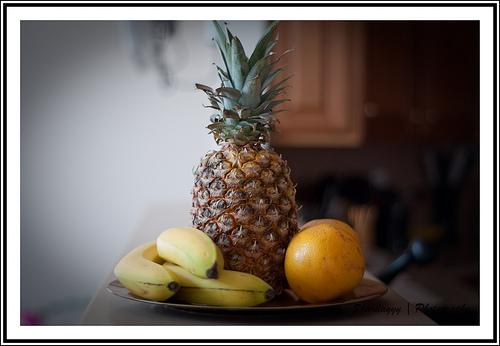What kind of tall fruit is in the center of the fruit plate? Please explain your reasoning. pineapple. The fruit is pineapple. 